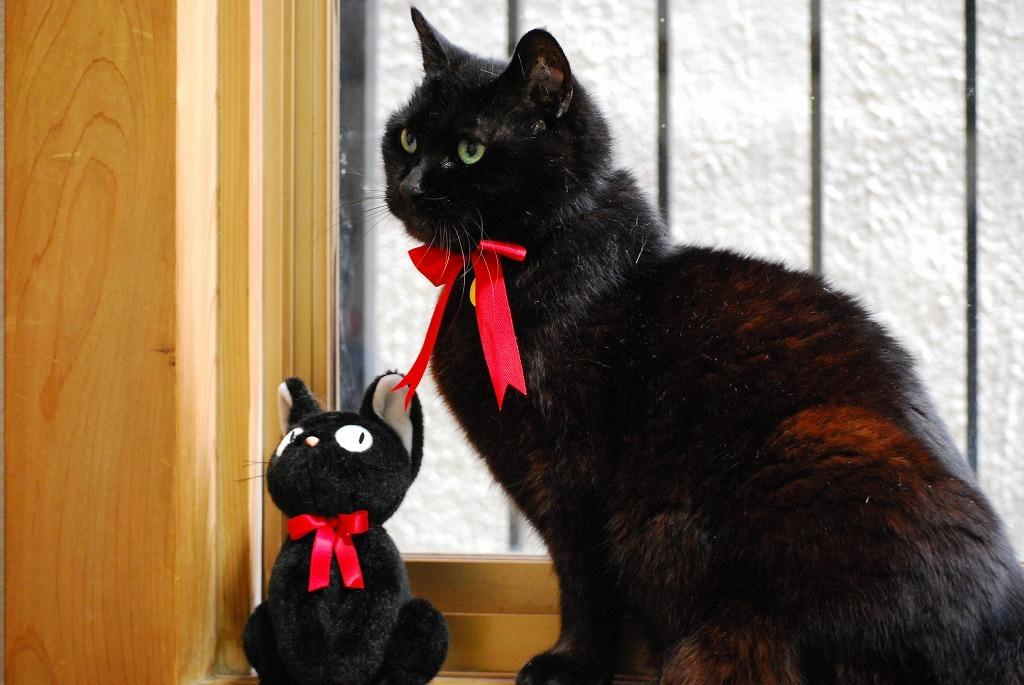What type of animal is in the image? There is a cat in the image. Where is the toy located in the image? The toy is near the window in the image. What color are the ribbons tied to the cat and the toy? The ribbons tied to the cat and the toy are red in color. What type of powder is being used to make the cracker in the image? There is no powder or cracker present in the image. 